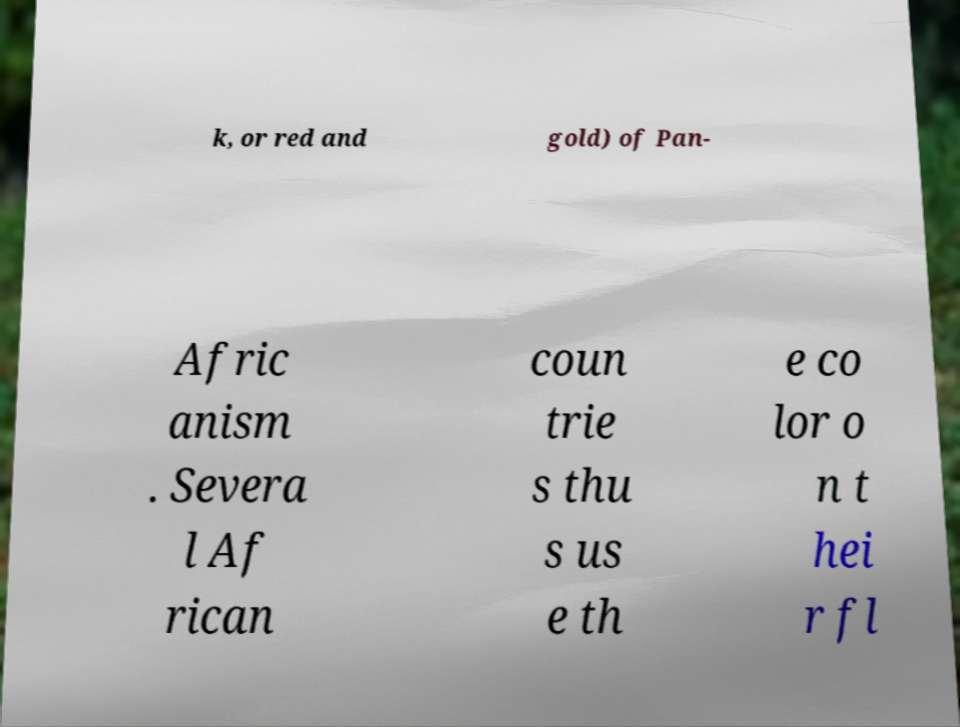Can you read and provide the text displayed in the image?This photo seems to have some interesting text. Can you extract and type it out for me? k, or red and gold) of Pan- Afric anism . Severa l Af rican coun trie s thu s us e th e co lor o n t hei r fl 